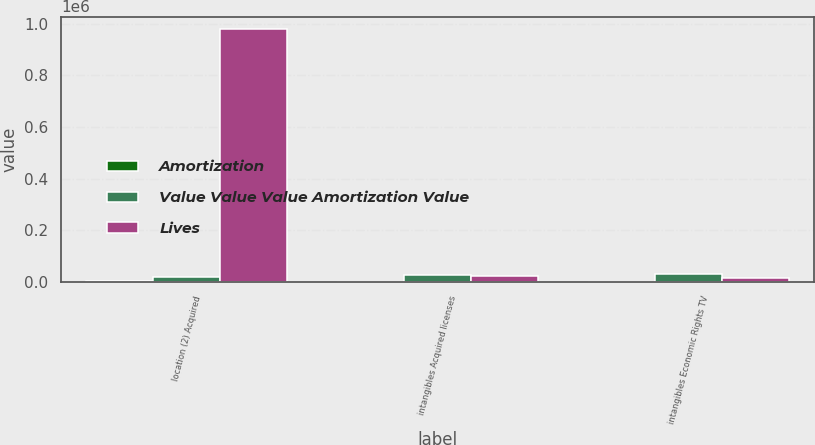Convert chart. <chart><loc_0><loc_0><loc_500><loc_500><stacked_bar_chart><ecel><fcel>location (2) Acquired<fcel>intangibles Acquired licenses<fcel>intangibles Economic Rights TV<nl><fcel>Amortization<fcel>1520<fcel>320<fcel>70<nl><fcel>Value Value Value Amortization Value<fcel>17368.5<fcel>26079<fcel>28954<nl><fcel>Lives<fcel>979264<fcel>20835<fcel>13902<nl></chart> 